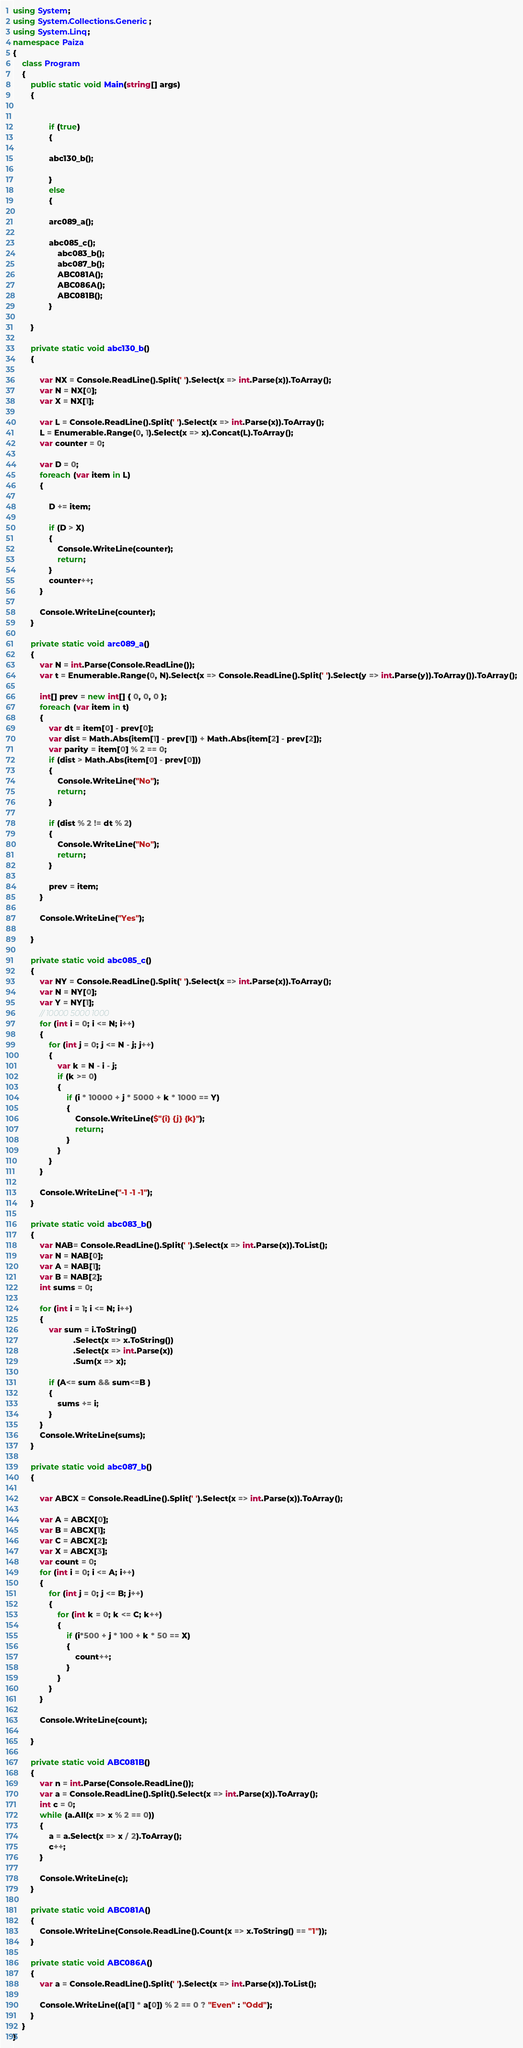Convert code to text. <code><loc_0><loc_0><loc_500><loc_500><_C#_>using System;
using System.Collections.Generic;
using System.Linq;
namespace Paiza
{
    class Program
    {
        public static void Main(string[] args)
        {


                if (true)
                {

                abc130_b();

                }
                else
                {

                arc089_a();

                abc085_c();
                    abc083_b();
                    abc087_b();
                    ABC081A();
                    ABC086A();
                    ABC081B();
                }
            
        }

        private static void abc130_b()
        {

            var NX = Console.ReadLine().Split(' ').Select(x => int.Parse(x)).ToArray();
            var N = NX[0];
            var X = NX[1];

            var L = Console.ReadLine().Split(' ').Select(x => int.Parse(x)).ToArray();
            L = Enumerable.Range(0, 1).Select(x => x).Concat(L).ToArray();
            var counter = 0;

            var D = 0;
            foreach (var item in L)
            {

                D += item;

                if (D > X)
                {
                    Console.WriteLine(counter);
                    return; 
                }
                counter++;
            }

            Console.WriteLine(counter);
        }

        private static void arc089_a()
        {
            var N = int.Parse(Console.ReadLine());
            var t = Enumerable.Range(0, N).Select(x => Console.ReadLine().Split(' ').Select(y => int.Parse(y)).ToArray()).ToArray();

            int[] prev = new int[] { 0, 0, 0 };
            foreach (var item in t)
            {
                var dt = item[0] - prev[0];
                var dist = Math.Abs(item[1] - prev[1]) + Math.Abs(item[2] - prev[2]);
                var parity = item[0] % 2 == 0;
                if (dist > Math.Abs(item[0] - prev[0])) 
                {
                    Console.WriteLine("No");
                    return;
                }

                if (dist % 2 != dt % 2) 
                {
                    Console.WriteLine("No");
                    return;
                }

                prev = item;
            }

            Console.WriteLine("Yes");

        }

        private static void abc085_c()
        {
            var NY = Console.ReadLine().Split(' ').Select(x => int.Parse(x)).ToArray();
            var N = NY[0];
            var Y = NY[1];
            // 10000 5000 1000
            for (int i = 0; i <= N; i++)
            {
                for (int j = 0; j <= N - j; j++)
                {
                    var k = N - i - j;
                    if (k >= 0)
                    {
                        if (i * 10000 + j * 5000 + k * 1000 == Y)
                        {
                            Console.WriteLine($"{i} {j} {k}");
                            return;
                        }
                    }
                }
            }

            Console.WriteLine("-1 -1 -1");
        }

        private static void abc083_b()
        {
            var NAB= Console.ReadLine().Split(' ').Select(x => int.Parse(x)).ToList();
            var N = NAB[0];
            var A = NAB[1];
            var B = NAB[2];
            int sums = 0;

            for (int i = 1; i <= N; i++)
            {
                var sum = i.ToString()
                           .Select(x => x.ToString())
                           .Select(x => int.Parse(x))
                           .Sum(x => x);

                if (A<= sum && sum<=B )
                {
                    sums += i;
                }
            }
            Console.WriteLine(sums);
        }

        private static void abc087_b()
        {

            var ABCX = Console.ReadLine().Split(' ').Select(x => int.Parse(x)).ToArray();

            var A = ABCX[0];
            var B = ABCX[1];
            var C = ABCX[2];
            var X = ABCX[3];
            var count = 0;
            for (int i = 0; i <= A; i++)
            {
                for (int j = 0; j <= B; j++)
                {
                    for (int k = 0; k <= C; k++)
                    {
                        if (i*500 + j * 100 + k * 50 == X)
                        {
                            count++;
                        }
                    }
                }
            }

            Console.WriteLine(count);

        }

        private static void ABC081B()
        {
            var n = int.Parse(Console.ReadLine());
            var a = Console.ReadLine().Split().Select(x => int.Parse(x)).ToArray();
            int c = 0;
            while (a.All(x => x % 2 == 0))
            {
                a = a.Select(x => x / 2).ToArray();
                c++;
            }

            Console.WriteLine(c);
        }

        private static void ABC081A()
        {
            Console.WriteLine(Console.ReadLine().Count(x => x.ToString() == "1"));
        }

        private static void ABC086A()
        {
            var a = Console.ReadLine().Split(' ').Select(x => int.Parse(x)).ToList();

            Console.WriteLine((a[1] * a[0]) % 2 == 0 ? "Even" : "Odd");
        }
    }
}
</code> 